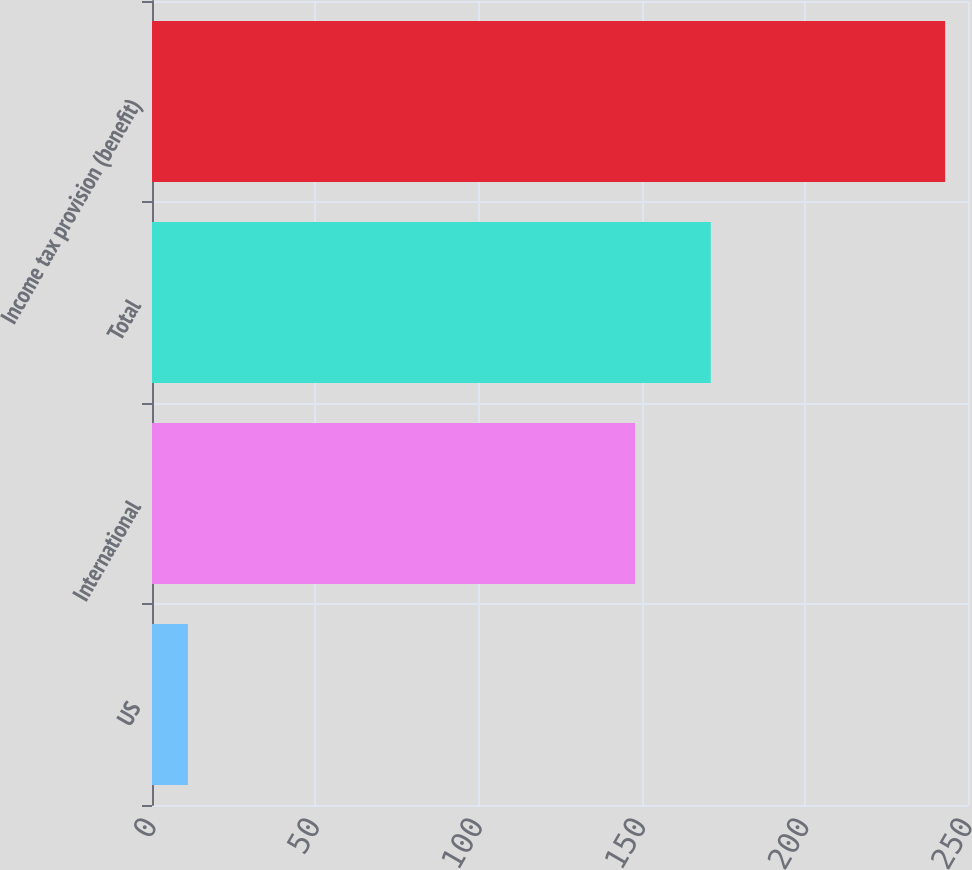Convert chart to OTSL. <chart><loc_0><loc_0><loc_500><loc_500><bar_chart><fcel>US<fcel>International<fcel>Total<fcel>Income tax provision (benefit)<nl><fcel>11<fcel>148<fcel>171.2<fcel>243<nl></chart> 